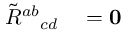Convert formula to latex. <formula><loc_0><loc_0><loc_500><loc_500>\begin{array} { r l } { \tilde { R } ^ { a b _ { c d } } & = 0 } \end{array}</formula> 